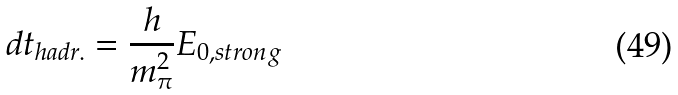<formula> <loc_0><loc_0><loc_500><loc_500>d t _ { h a d r . } = \frac { h } { m _ { \pi } ^ { 2 } } E _ { 0 , s t r o n g }</formula> 